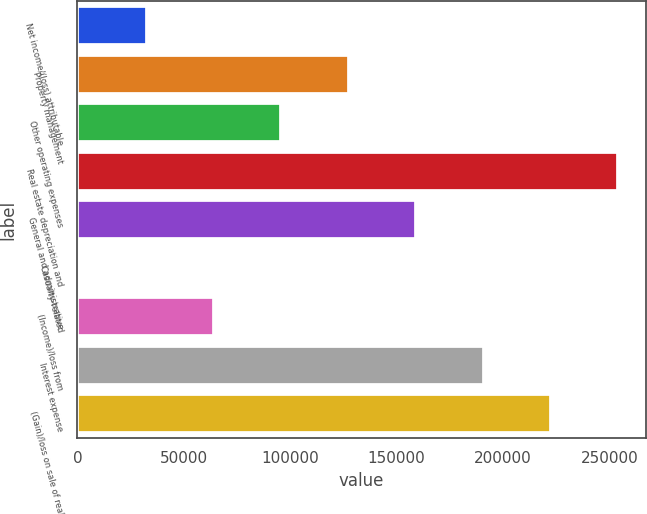Convert chart. <chart><loc_0><loc_0><loc_500><loc_500><bar_chart><fcel>Net income/(loss) attributable<fcel>Property management<fcel>Other operating expenses<fcel>Real estate depreciation and<fcel>General and administrative<fcel>Casualty-related<fcel>(Income)/loss from<fcel>Interest expense<fcel>(Gain)/loss on sale of real<nl><fcel>32518.4<fcel>127545<fcel>95869.2<fcel>254246<fcel>159220<fcel>843<fcel>64193.8<fcel>190895<fcel>222571<nl></chart> 